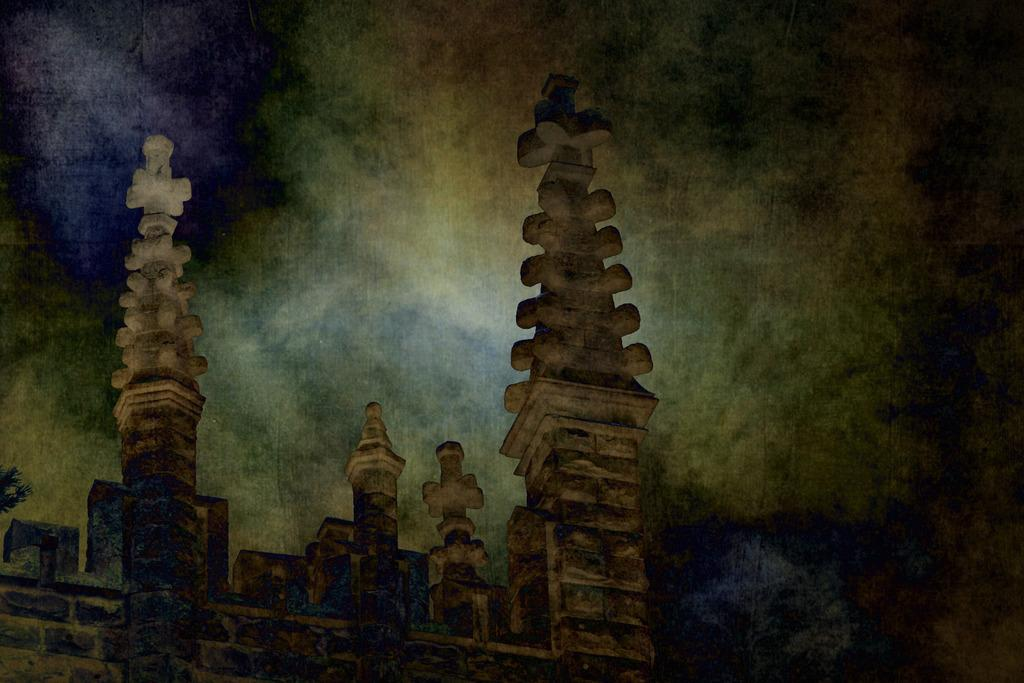What is the main subject of the image? The main subject of the image is a castle construction. What architectural features can be seen on the castle? Ancient pillars are visible on the top of the castle. What is visible in the background of the image? The sky is visible in the image. What can be observed in the sky? Clouds are present in the sky. What type of suggestion can be seen in the image? There is no suggestion present in the image; it depicts a castle construction with ancient pillars and a sky with clouds. Can you tell me how many hens are visible in the image? There are no hens present in the image. 